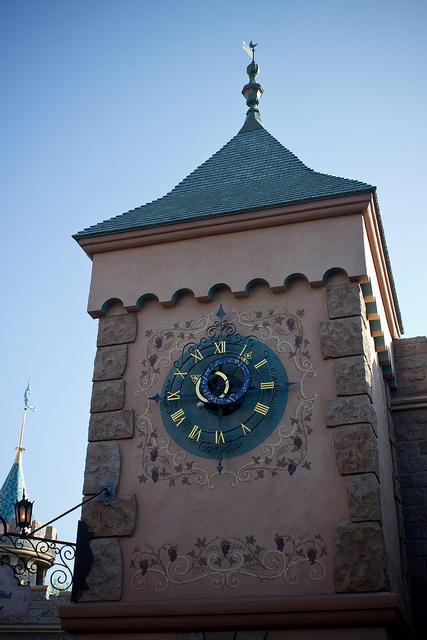What time does it say on the clock?
Write a very short answer. 8:45. Is this a church?
Quick response, please. Yes. What color is the face of the clock?
Short answer required. Blue. 